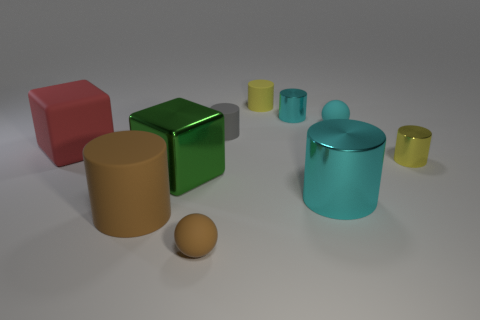Subtract all brown cylinders. How many cylinders are left? 5 Subtract all gray rubber cylinders. How many cylinders are left? 5 Subtract all brown cylinders. Subtract all red cubes. How many cylinders are left? 5 Subtract all spheres. How many objects are left? 8 Subtract all tiny brown matte balls. Subtract all red rubber objects. How many objects are left? 8 Add 5 tiny yellow metallic objects. How many tiny yellow metallic objects are left? 6 Add 7 small yellow things. How many small yellow things exist? 9 Subtract 0 gray cubes. How many objects are left? 10 